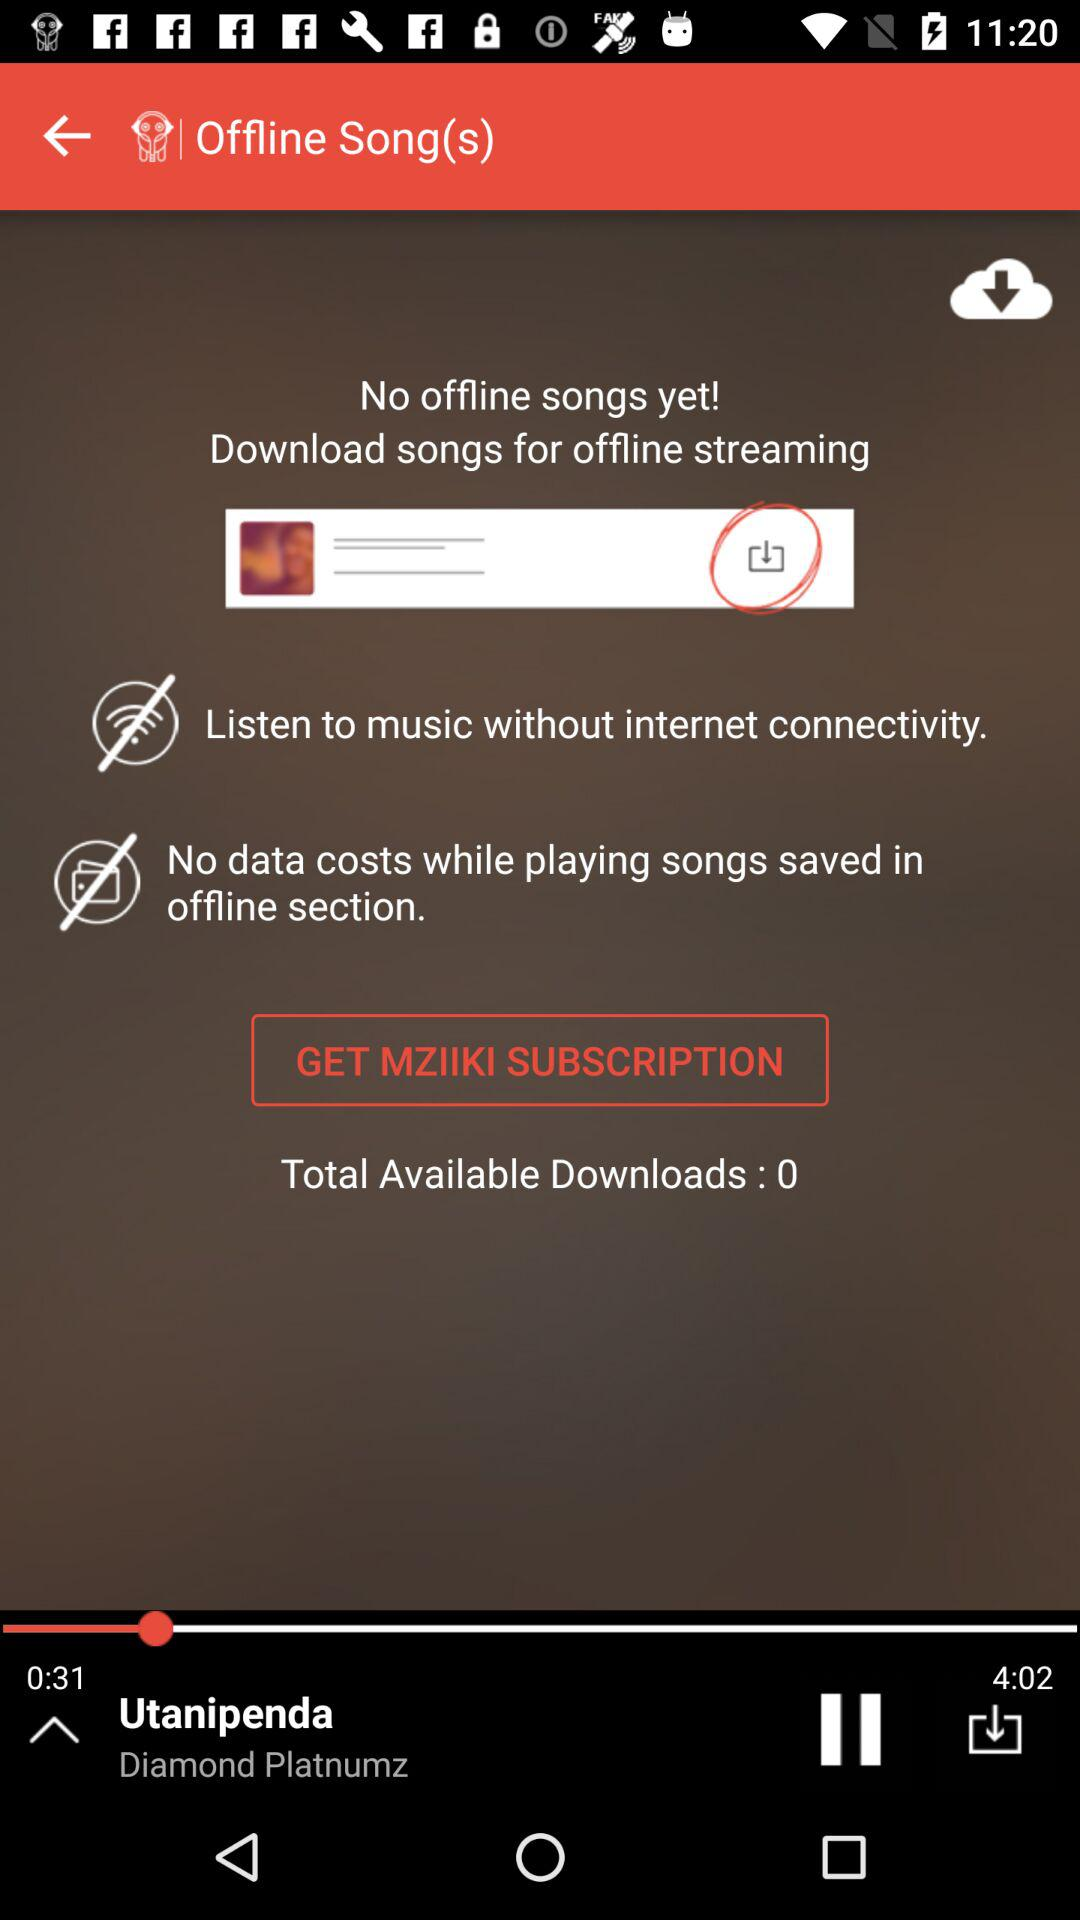What's the duration of the song? The duration of the song is 4 minutes and 2 seconds. 